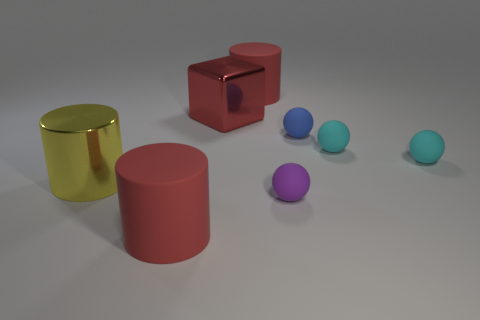Can you tell me which objects in the photo are reflective? The golden yellow cylinder and the red cube exhibit reflective properties, as indicated by the highlights and slight mirroring on their surfaces. 